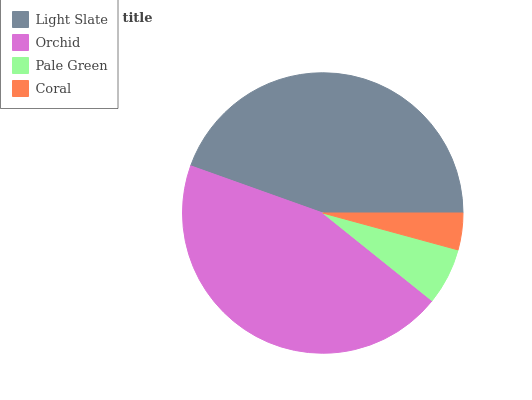Is Coral the minimum?
Answer yes or no. Yes. Is Orchid the maximum?
Answer yes or no. Yes. Is Pale Green the minimum?
Answer yes or no. No. Is Pale Green the maximum?
Answer yes or no. No. Is Orchid greater than Pale Green?
Answer yes or no. Yes. Is Pale Green less than Orchid?
Answer yes or no. Yes. Is Pale Green greater than Orchid?
Answer yes or no. No. Is Orchid less than Pale Green?
Answer yes or no. No. Is Light Slate the high median?
Answer yes or no. Yes. Is Pale Green the low median?
Answer yes or no. Yes. Is Pale Green the high median?
Answer yes or no. No. Is Light Slate the low median?
Answer yes or no. No. 